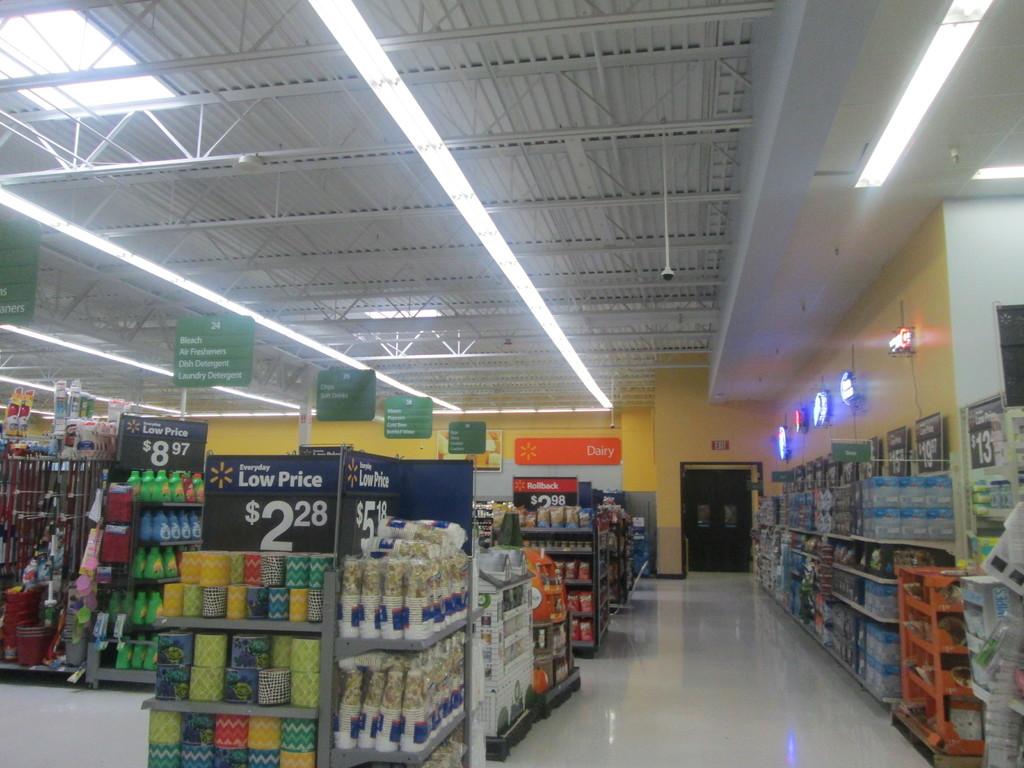In which aisle do you find bleach?
Provide a short and direct response. 24. What is the price shown on front stand?
Offer a terse response. 2.28. 